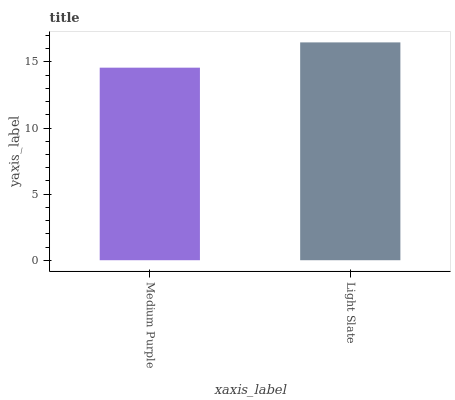Is Medium Purple the minimum?
Answer yes or no. Yes. Is Light Slate the maximum?
Answer yes or no. Yes. Is Light Slate the minimum?
Answer yes or no. No. Is Light Slate greater than Medium Purple?
Answer yes or no. Yes. Is Medium Purple less than Light Slate?
Answer yes or no. Yes. Is Medium Purple greater than Light Slate?
Answer yes or no. No. Is Light Slate less than Medium Purple?
Answer yes or no. No. Is Light Slate the high median?
Answer yes or no. Yes. Is Medium Purple the low median?
Answer yes or no. Yes. Is Medium Purple the high median?
Answer yes or no. No. Is Light Slate the low median?
Answer yes or no. No. 